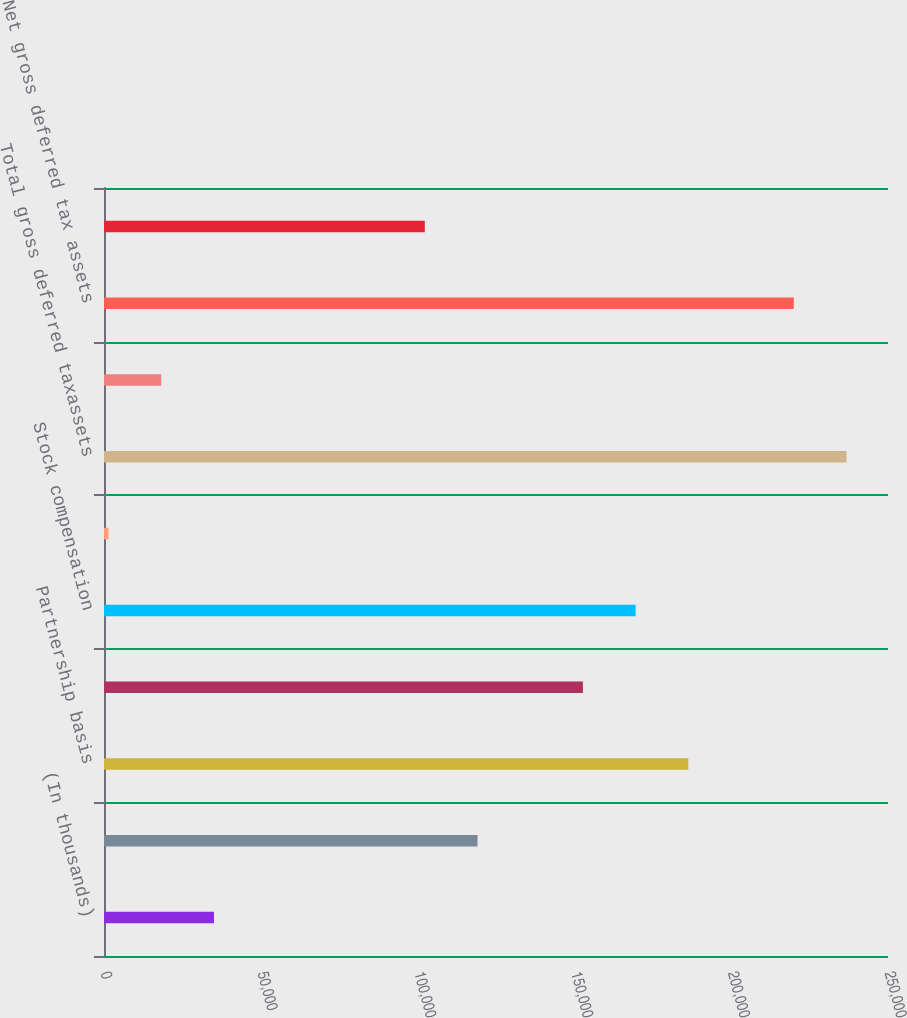Convert chart. <chart><loc_0><loc_0><loc_500><loc_500><bar_chart><fcel>(In thousands)<fcel>Accrued expenses<fcel>Partnership basis<fcel>Depreciation and amortization<fcel>Stock compensation<fcel>Capital loss carry forward<fcel>Total gross deferred taxassets<fcel>Less valuation allowance<fcel>Net gross deferred tax assets<fcel>Finance lease obligations<nl><fcel>35061.8<fcel>119104<fcel>186337<fcel>152721<fcel>169529<fcel>1445<fcel>236763<fcel>18253.4<fcel>219954<fcel>102295<nl></chart> 